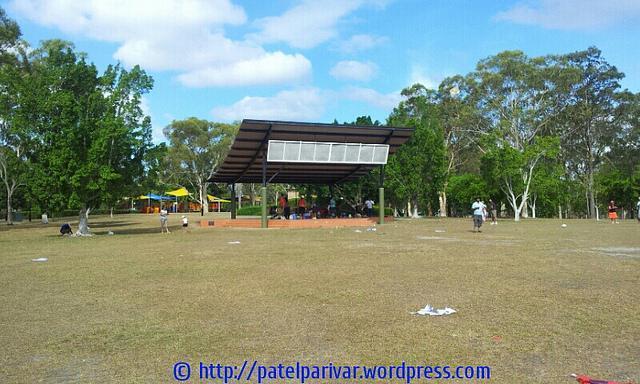How many doors on the bus are closed?
Give a very brief answer. 0. 